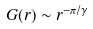<formula> <loc_0><loc_0><loc_500><loc_500>G ( r ) \sim r ^ { - \pi / \gamma }</formula> 